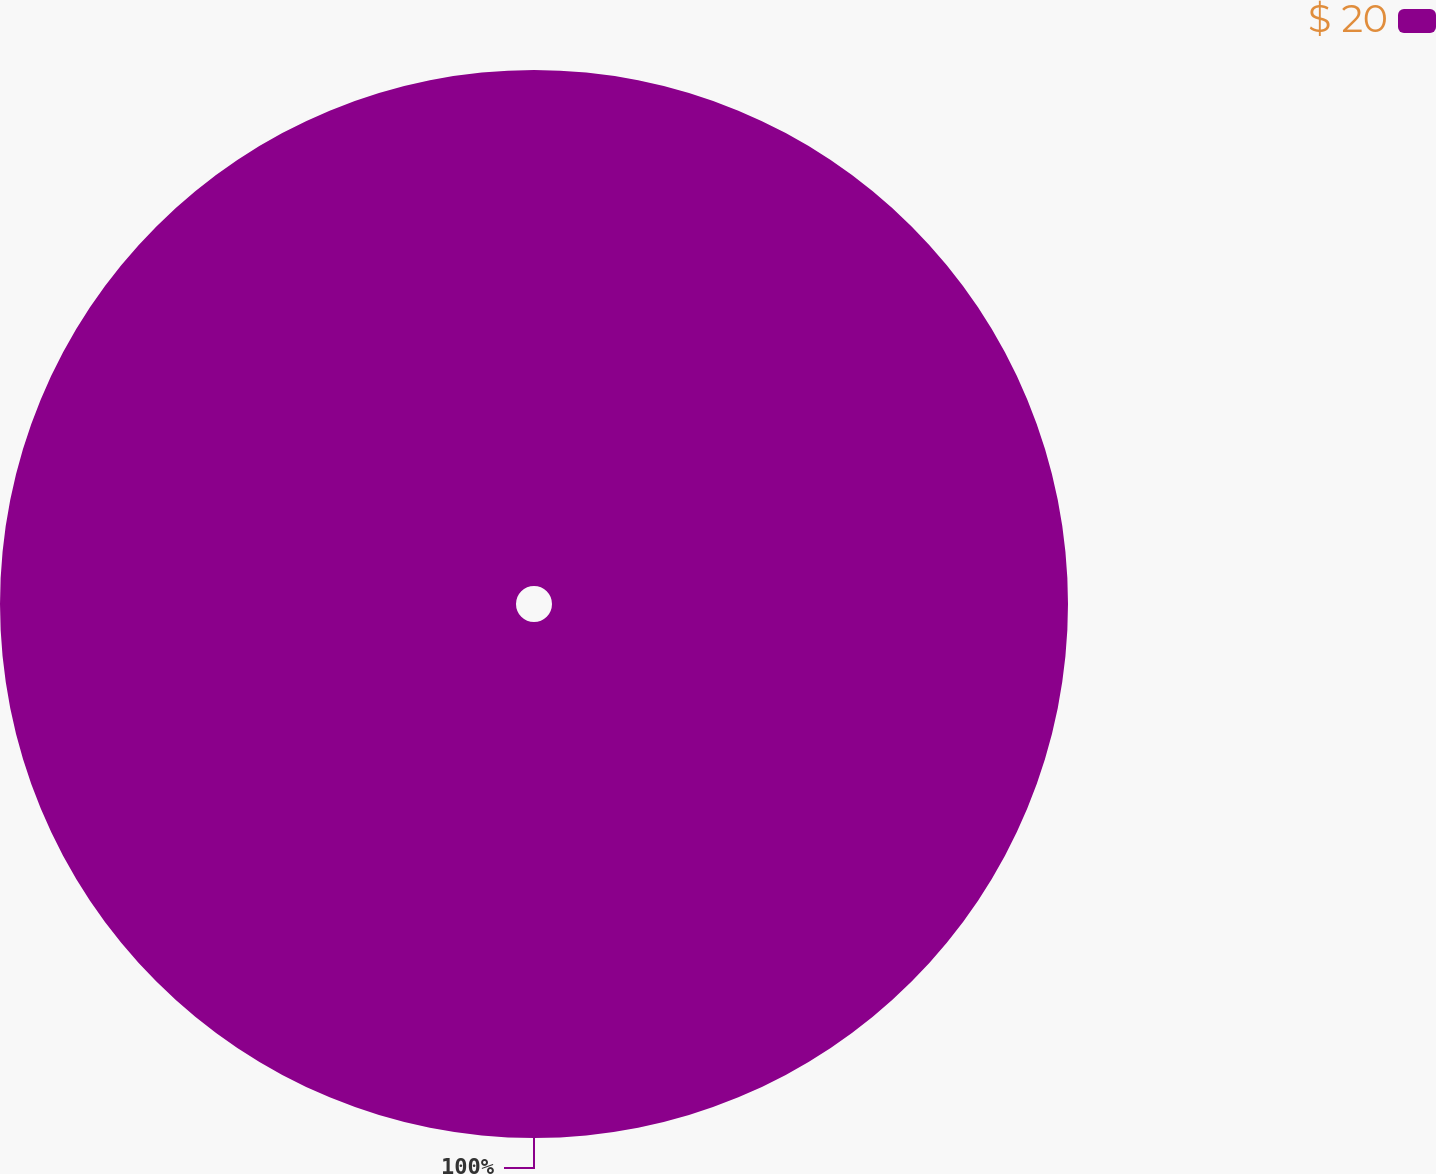<chart> <loc_0><loc_0><loc_500><loc_500><pie_chart><fcel>$ 20<nl><fcel>100.0%<nl></chart> 